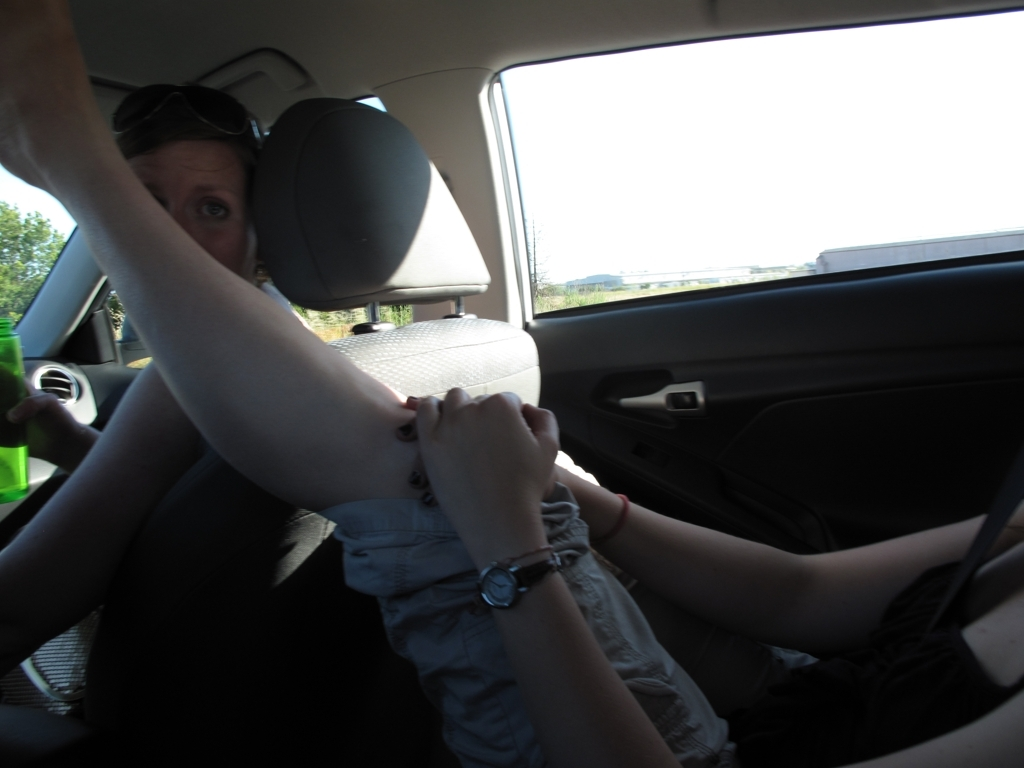Can you describe what's happening in the scene? It appears to be a candid moment captured inside a vehicle, where a person in the driver's seat is making an expressive gesture toward the camera, possibly to shield their face. It seems informal and unplanned. What might be the reason for their gesture? The individual could be reacting playfully or trying to avoid the camera for privacy reasons. It's also possible that they were simply caught off guard and are instinctively blocking the camera's view. 